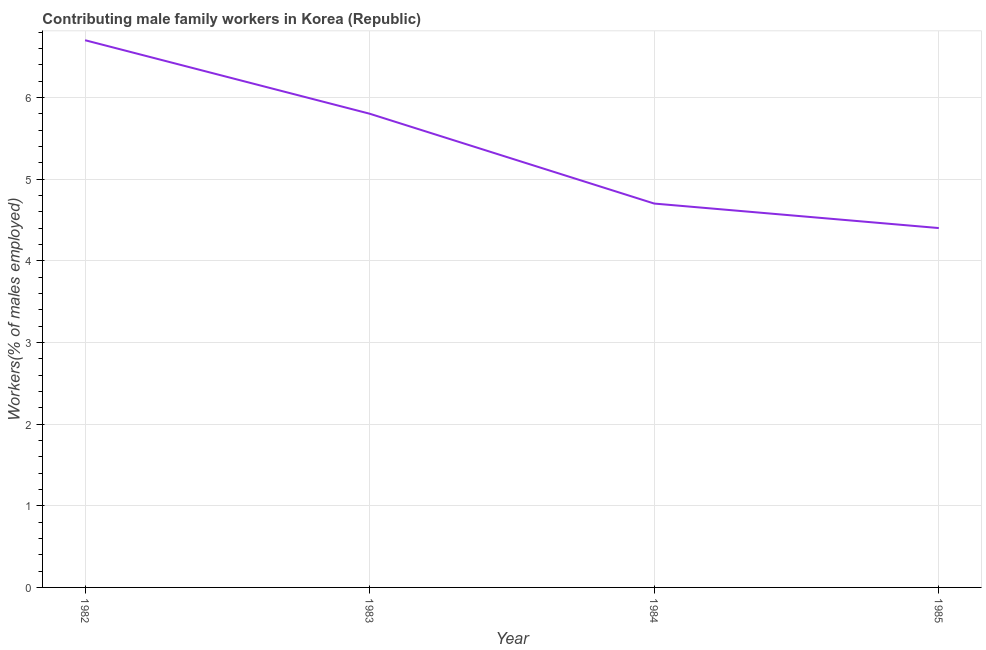What is the contributing male family workers in 1984?
Provide a succinct answer. 4.7. Across all years, what is the maximum contributing male family workers?
Provide a succinct answer. 6.7. Across all years, what is the minimum contributing male family workers?
Your response must be concise. 4.4. In which year was the contributing male family workers minimum?
Give a very brief answer. 1985. What is the sum of the contributing male family workers?
Make the answer very short. 21.6. What is the difference between the contributing male family workers in 1982 and 1983?
Ensure brevity in your answer.  0.9. What is the average contributing male family workers per year?
Your answer should be very brief. 5.4. What is the median contributing male family workers?
Keep it short and to the point. 5.25. Do a majority of the years between 1982 and 1984 (inclusive) have contributing male family workers greater than 4.4 %?
Make the answer very short. Yes. What is the ratio of the contributing male family workers in 1982 to that in 1984?
Give a very brief answer. 1.43. Is the contributing male family workers in 1982 less than that in 1983?
Provide a succinct answer. No. Is the difference between the contributing male family workers in 1984 and 1985 greater than the difference between any two years?
Your answer should be very brief. No. What is the difference between the highest and the second highest contributing male family workers?
Give a very brief answer. 0.9. What is the difference between the highest and the lowest contributing male family workers?
Your response must be concise. 2.3. In how many years, is the contributing male family workers greater than the average contributing male family workers taken over all years?
Give a very brief answer. 2. How many lines are there?
Provide a succinct answer. 1. What is the difference between two consecutive major ticks on the Y-axis?
Your answer should be very brief. 1. Does the graph contain grids?
Your response must be concise. Yes. What is the title of the graph?
Your response must be concise. Contributing male family workers in Korea (Republic). What is the label or title of the Y-axis?
Offer a very short reply. Workers(% of males employed). What is the Workers(% of males employed) in 1982?
Make the answer very short. 6.7. What is the Workers(% of males employed) in 1983?
Keep it short and to the point. 5.8. What is the Workers(% of males employed) of 1984?
Your response must be concise. 4.7. What is the Workers(% of males employed) in 1985?
Make the answer very short. 4.4. What is the difference between the Workers(% of males employed) in 1982 and 1983?
Offer a very short reply. 0.9. What is the difference between the Workers(% of males employed) in 1982 and 1984?
Offer a terse response. 2. What is the difference between the Workers(% of males employed) in 1983 and 1984?
Your answer should be very brief. 1.1. What is the difference between the Workers(% of males employed) in 1983 and 1985?
Make the answer very short. 1.4. What is the ratio of the Workers(% of males employed) in 1982 to that in 1983?
Offer a very short reply. 1.16. What is the ratio of the Workers(% of males employed) in 1982 to that in 1984?
Give a very brief answer. 1.43. What is the ratio of the Workers(% of males employed) in 1982 to that in 1985?
Provide a short and direct response. 1.52. What is the ratio of the Workers(% of males employed) in 1983 to that in 1984?
Give a very brief answer. 1.23. What is the ratio of the Workers(% of males employed) in 1983 to that in 1985?
Make the answer very short. 1.32. What is the ratio of the Workers(% of males employed) in 1984 to that in 1985?
Keep it short and to the point. 1.07. 